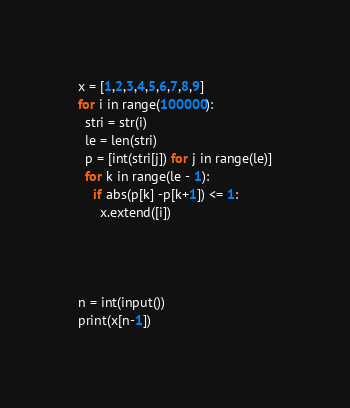Convert code to text. <code><loc_0><loc_0><loc_500><loc_500><_Python_>x = [1,2,3,4,5,6,7,8,9]
for i in range(100000):
  stri = str(i)
  le = len(stri)
  p = [int(stri[j]) for j in range(le)]
  for k in range(le - 1):
    if abs(p[k] -p[k+1]) <= 1:
      x.extend([i])




n = int(input())
print(x[n-1])</code> 